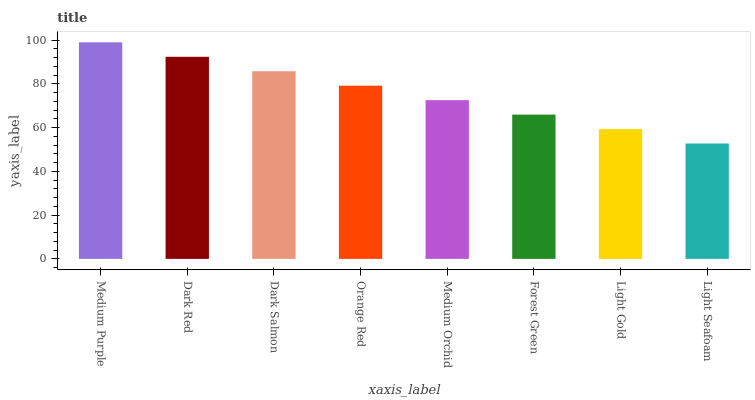Is Light Seafoam the minimum?
Answer yes or no. Yes. Is Medium Purple the maximum?
Answer yes or no. Yes. Is Dark Red the minimum?
Answer yes or no. No. Is Dark Red the maximum?
Answer yes or no. No. Is Medium Purple greater than Dark Red?
Answer yes or no. Yes. Is Dark Red less than Medium Purple?
Answer yes or no. Yes. Is Dark Red greater than Medium Purple?
Answer yes or no. No. Is Medium Purple less than Dark Red?
Answer yes or no. No. Is Orange Red the high median?
Answer yes or no. Yes. Is Medium Orchid the low median?
Answer yes or no. Yes. Is Light Seafoam the high median?
Answer yes or no. No. Is Light Seafoam the low median?
Answer yes or no. No. 